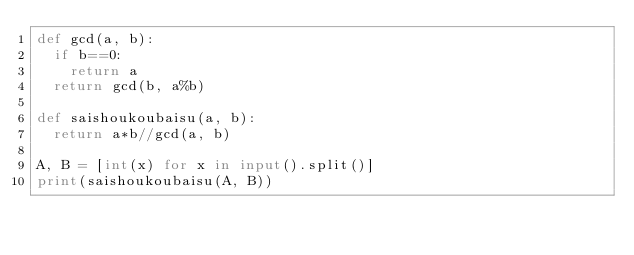<code> <loc_0><loc_0><loc_500><loc_500><_Python_>def gcd(a, b):
  if b==0:
    return a
  return gcd(b, a%b)

def saishoukoubaisu(a, b):
  return a*b//gcd(a, b)

A, B = [int(x) for x in input().split()]
print(saishoukoubaisu(A, B))
</code> 